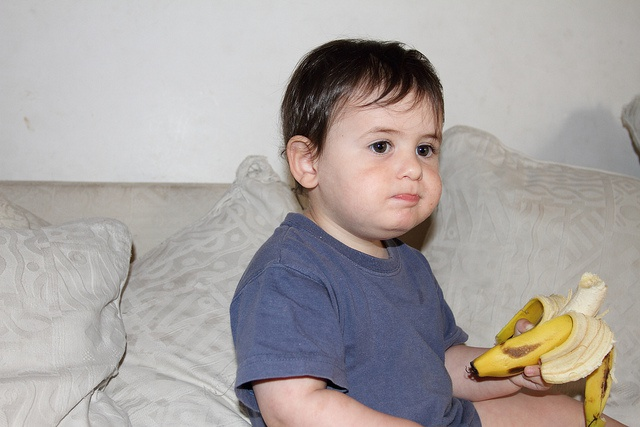Describe the objects in this image and their specific colors. I can see couch in darkgray and lightgray tones, people in darkgray, gray, tan, and black tones, and banana in darkgray, tan, and khaki tones in this image. 